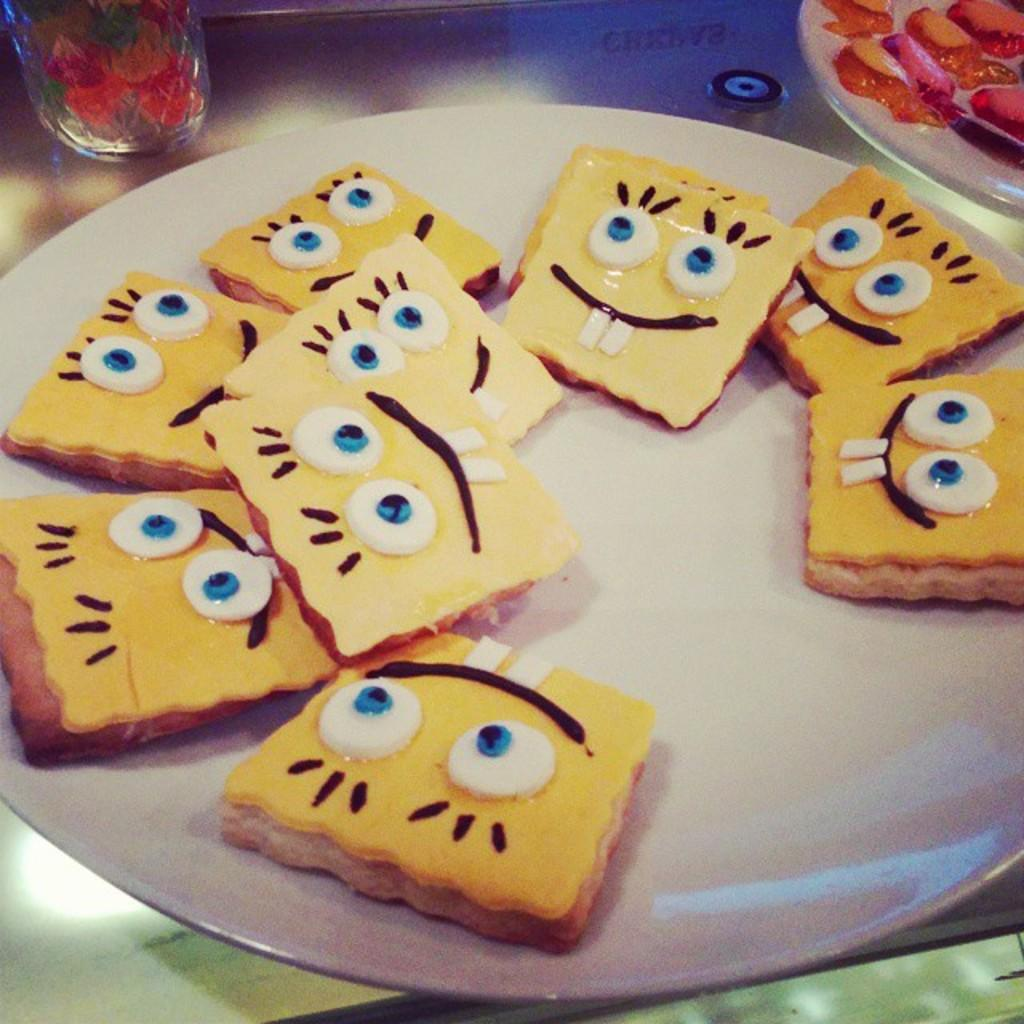What can be found on the plates in the image? There are food items in the plates in the image. Can you describe any other objects in the image besides the plates? Yes, there is a glass in the top left corner of the image. What type of anger can be seen in the image? There is no anger present in the image; it only contains food items on plates and a glass. 